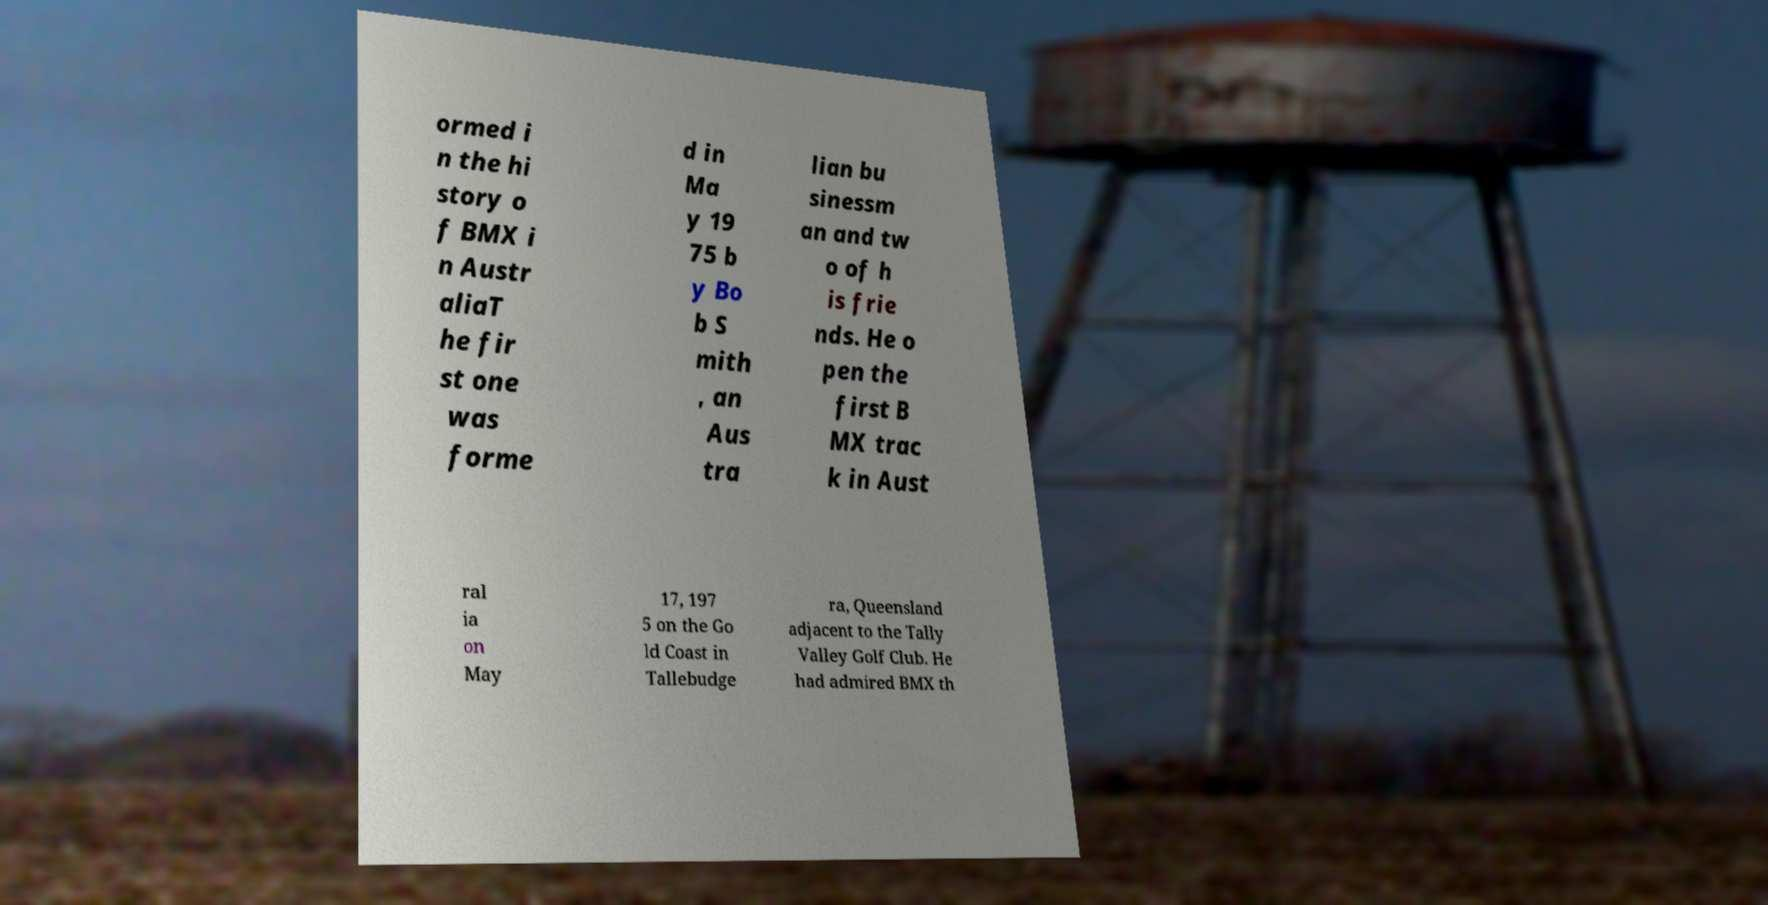Please read and relay the text visible in this image. What does it say? ormed i n the hi story o f BMX i n Austr aliaT he fir st one was forme d in Ma y 19 75 b y Bo b S mith , an Aus tra lian bu sinessm an and tw o of h is frie nds. He o pen the first B MX trac k in Aust ral ia on May 17, 197 5 on the Go ld Coast in Tallebudge ra, Queensland adjacent to the Tally Valley Golf Club. He had admired BMX th 